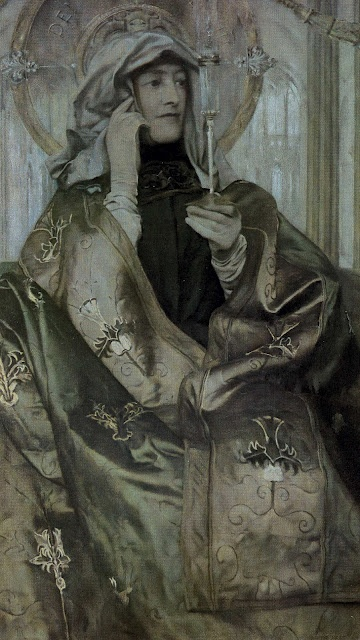How does the background contribute to the overall mood of the image? The background, featuring a subtle pale gray with a delicate pattern of leaves and branches, provides a serene and calming effect that enhances the overall mood of the image. It does not distract from the subject but rather complements her contemplative expression and elegant attire. This subdued and harmonious backdrop allows the viewer to focus on the intricate details of the woman's robe and the delicate flower she holds, reinforcing the peaceful and reflective atmosphere of the portrait. 